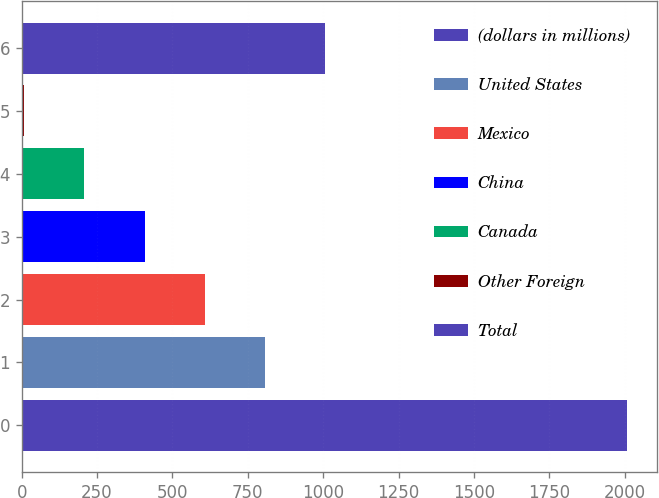Convert chart. <chart><loc_0><loc_0><loc_500><loc_500><bar_chart><fcel>(dollars in millions)<fcel>United States<fcel>Mexico<fcel>China<fcel>Canada<fcel>Other Foreign<fcel>Total<nl><fcel>2006<fcel>807.14<fcel>607.33<fcel>407.52<fcel>207.71<fcel>7.9<fcel>1006.95<nl></chart> 